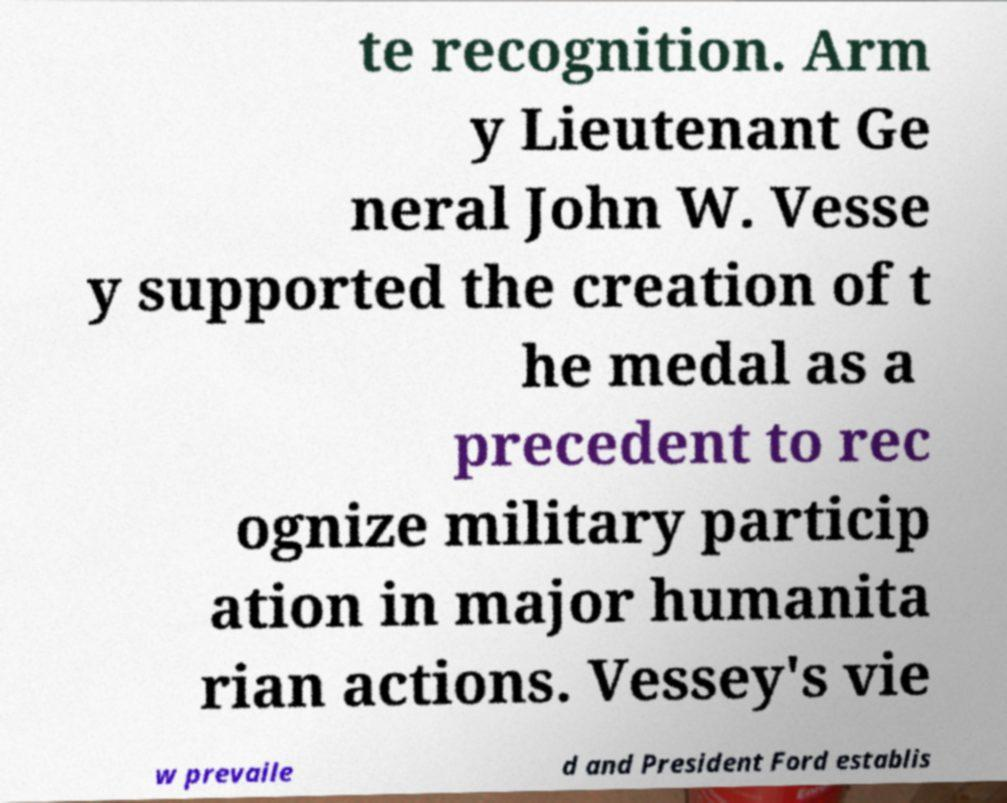Could you assist in decoding the text presented in this image and type it out clearly? te recognition. Arm y Lieutenant Ge neral John W. Vesse y supported the creation of t he medal as a precedent to rec ognize military particip ation in major humanita rian actions. Vessey's vie w prevaile d and President Ford establis 